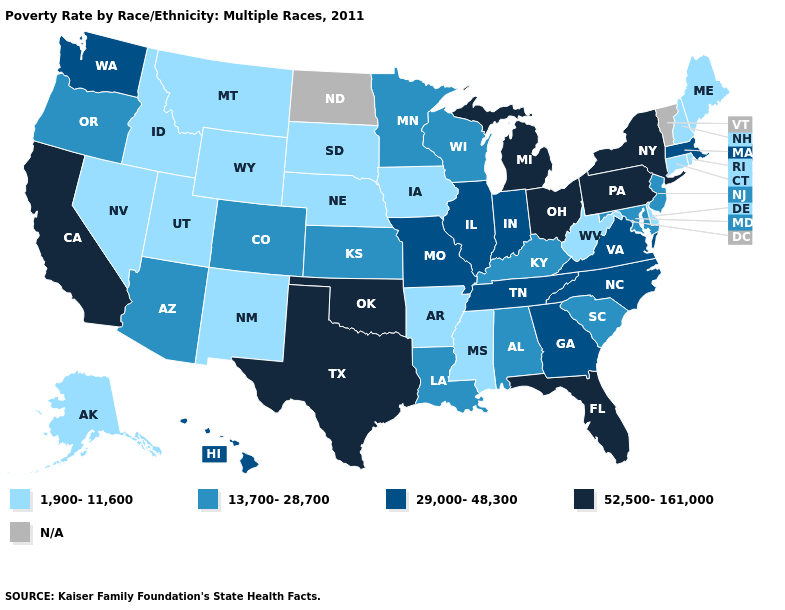Does Michigan have the highest value in the MidWest?
Quick response, please. Yes. What is the lowest value in states that border Virginia?
Answer briefly. 1,900-11,600. Name the states that have a value in the range 52,500-161,000?
Answer briefly. California, Florida, Michigan, New York, Ohio, Oklahoma, Pennsylvania, Texas. Does Connecticut have the lowest value in the Northeast?
Give a very brief answer. Yes. What is the highest value in the USA?
Quick response, please. 52,500-161,000. Which states have the lowest value in the USA?
Answer briefly. Alaska, Arkansas, Connecticut, Delaware, Idaho, Iowa, Maine, Mississippi, Montana, Nebraska, Nevada, New Hampshire, New Mexico, Rhode Island, South Dakota, Utah, West Virginia, Wyoming. Does the map have missing data?
Short answer required. Yes. What is the highest value in the USA?
Write a very short answer. 52,500-161,000. What is the value of Missouri?
Keep it brief. 29,000-48,300. Name the states that have a value in the range 1,900-11,600?
Be succinct. Alaska, Arkansas, Connecticut, Delaware, Idaho, Iowa, Maine, Mississippi, Montana, Nebraska, Nevada, New Hampshire, New Mexico, Rhode Island, South Dakota, Utah, West Virginia, Wyoming. What is the value of Oregon?
Quick response, please. 13,700-28,700. Name the states that have a value in the range 13,700-28,700?
Give a very brief answer. Alabama, Arizona, Colorado, Kansas, Kentucky, Louisiana, Maryland, Minnesota, New Jersey, Oregon, South Carolina, Wisconsin. Does Georgia have the highest value in the USA?
Be succinct. No. What is the value of Illinois?
Write a very short answer. 29,000-48,300. What is the value of Mississippi?
Write a very short answer. 1,900-11,600. 